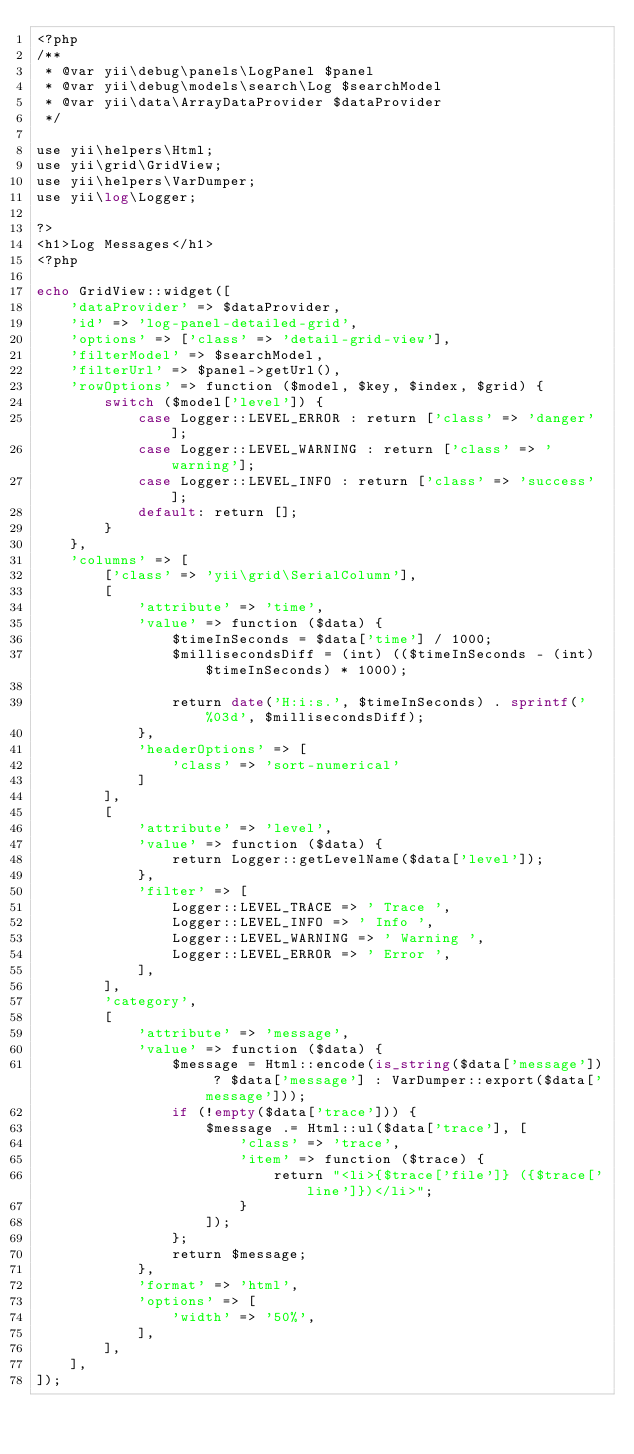Convert code to text. <code><loc_0><loc_0><loc_500><loc_500><_PHP_><?php
/**
 * @var yii\debug\panels\LogPanel $panel
 * @var yii\debug\models\search\Log $searchModel
 * @var yii\data\ArrayDataProvider $dataProvider
 */

use yii\helpers\Html;
use yii\grid\GridView;
use yii\helpers\VarDumper;
use yii\log\Logger;

?>
<h1>Log Messages</h1>
<?php

echo GridView::widget([
    'dataProvider' => $dataProvider,
    'id' => 'log-panel-detailed-grid',
    'options' => ['class' => 'detail-grid-view'],
    'filterModel' => $searchModel,
    'filterUrl' => $panel->getUrl(),
    'rowOptions' => function ($model, $key, $index, $grid) {
        switch ($model['level']) {
            case Logger::LEVEL_ERROR : return ['class' => 'danger'];
            case Logger::LEVEL_WARNING : return ['class' => 'warning'];
            case Logger::LEVEL_INFO : return ['class' => 'success'];
            default: return [];
        }
    },
    'columns' => [
        ['class' => 'yii\grid\SerialColumn'],
        [
            'attribute' => 'time',
            'value' => function ($data) {
                $timeInSeconds = $data['time'] / 1000;
                $millisecondsDiff = (int) (($timeInSeconds - (int) $timeInSeconds) * 1000);

                return date('H:i:s.', $timeInSeconds) . sprintf('%03d', $millisecondsDiff);
            },
            'headerOptions' => [
                'class' => 'sort-numerical'
            ]
        ],
        [
            'attribute' => 'level',
            'value' => function ($data) {
                return Logger::getLevelName($data['level']);
            },
            'filter' => [
                Logger::LEVEL_TRACE => ' Trace ',
                Logger::LEVEL_INFO => ' Info ',
                Logger::LEVEL_WARNING => ' Warning ',
                Logger::LEVEL_ERROR => ' Error ',
            ],
        ],
        'category',
        [
            'attribute' => 'message',
            'value' => function ($data) {
                $message = Html::encode(is_string($data['message']) ? $data['message'] : VarDumper::export($data['message']));
                if (!empty($data['trace'])) {
                    $message .= Html::ul($data['trace'], [
                        'class' => 'trace',
                        'item' => function ($trace) {
                            return "<li>{$trace['file']} ({$trace['line']})</li>";
                        }
                    ]);
                };
                return $message;
            },
            'format' => 'html',
            'options' => [
                'width' => '50%',
            ],
        ],
    ],
]);
</code> 